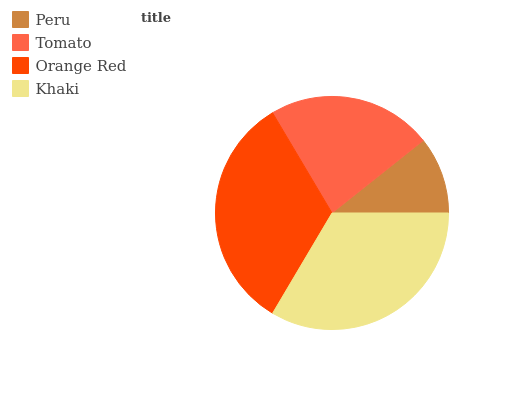Is Peru the minimum?
Answer yes or no. Yes. Is Khaki the maximum?
Answer yes or no. Yes. Is Tomato the minimum?
Answer yes or no. No. Is Tomato the maximum?
Answer yes or no. No. Is Tomato greater than Peru?
Answer yes or no. Yes. Is Peru less than Tomato?
Answer yes or no. Yes. Is Peru greater than Tomato?
Answer yes or no. No. Is Tomato less than Peru?
Answer yes or no. No. Is Orange Red the high median?
Answer yes or no. Yes. Is Tomato the low median?
Answer yes or no. Yes. Is Peru the high median?
Answer yes or no. No. Is Khaki the low median?
Answer yes or no. No. 